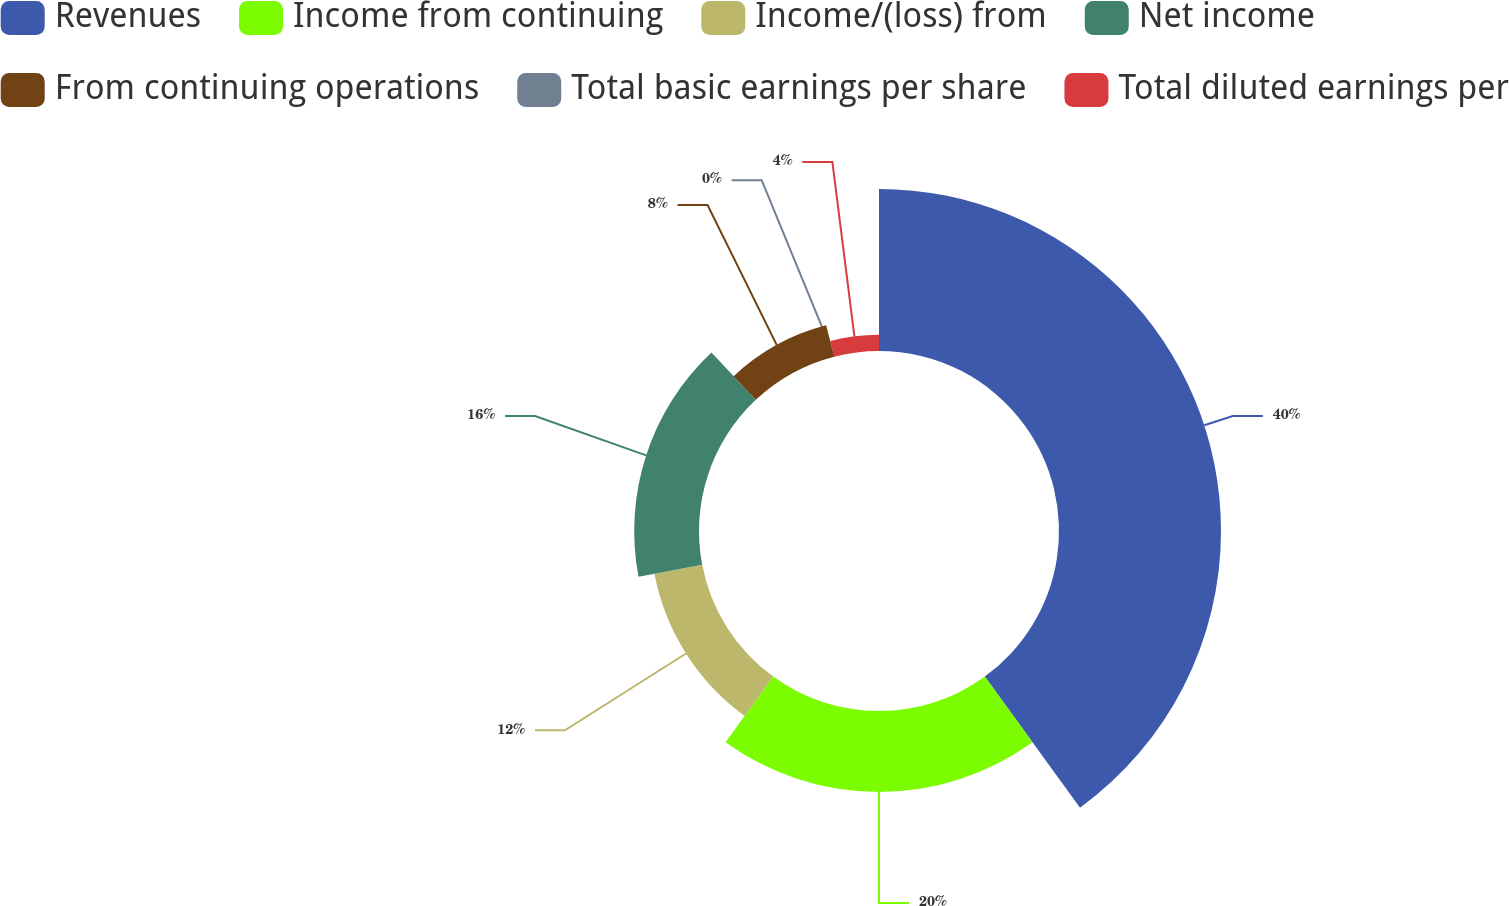<chart> <loc_0><loc_0><loc_500><loc_500><pie_chart><fcel>Revenues<fcel>Income from continuing<fcel>Income/(loss) from<fcel>Net income<fcel>From continuing operations<fcel>Total basic earnings per share<fcel>Total diluted earnings per<nl><fcel>40.0%<fcel>20.0%<fcel>12.0%<fcel>16.0%<fcel>8.0%<fcel>0.0%<fcel>4.0%<nl></chart> 